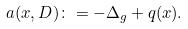Convert formula to latex. <formula><loc_0><loc_0><loc_500><loc_500>a ( x , D ) \colon = - \Delta _ { g } + q ( x ) .</formula> 